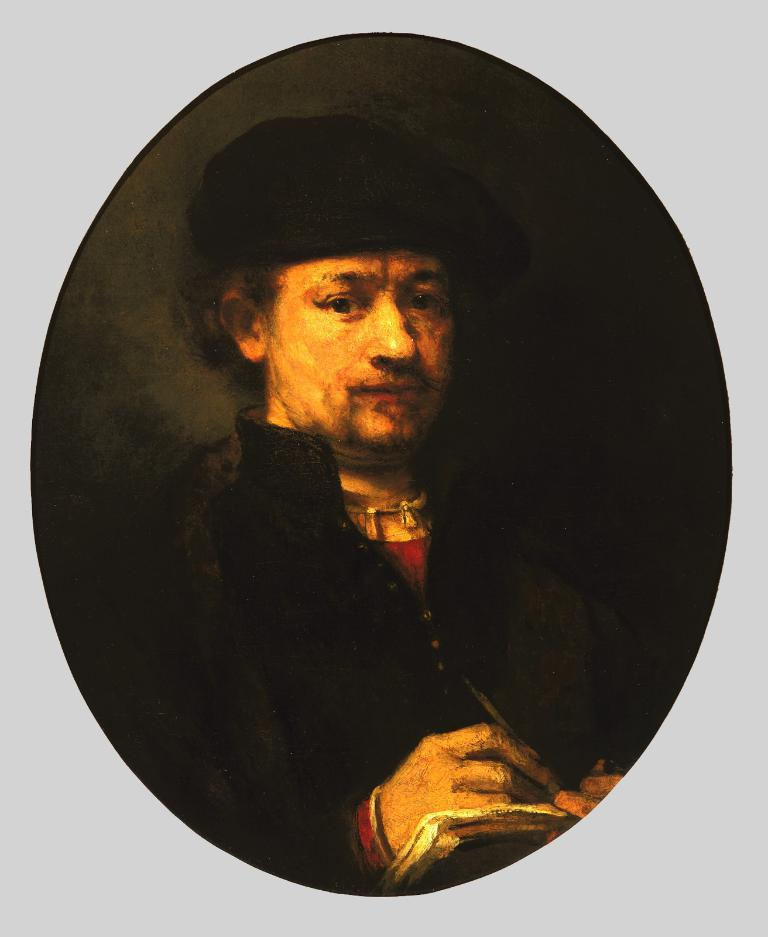What is the main subject of the image? There is a photo in the image. What is depicted in the photo? The photo contains a person. What is the person in the photo holding? The person is holding a book and a pen. What type of pain is the person in the photo experiencing? There is no indication in the image that the person in the photo is experiencing any pain. Is the person in the photo in debt? There is no information about the person's financial situation in the image. What type of metal is the pen made of in the image? The image does not provide information about the material of the pen. 